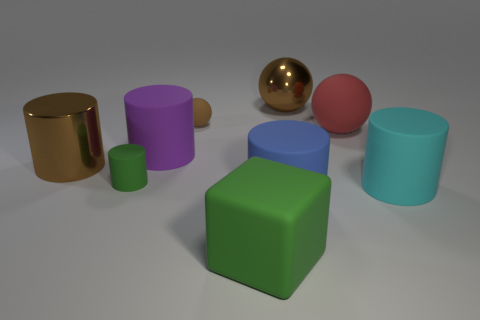Subtract all cyan matte cylinders. How many cylinders are left? 4 Subtract all blue cylinders. How many cylinders are left? 4 Subtract all red cylinders. Subtract all purple spheres. How many cylinders are left? 5 Add 1 green blocks. How many objects exist? 10 Subtract all balls. How many objects are left? 6 Add 3 cylinders. How many cylinders are left? 8 Add 6 big blue metallic cylinders. How many big blue metallic cylinders exist? 6 Subtract 1 red balls. How many objects are left? 8 Subtract all big cubes. Subtract all large red things. How many objects are left? 7 